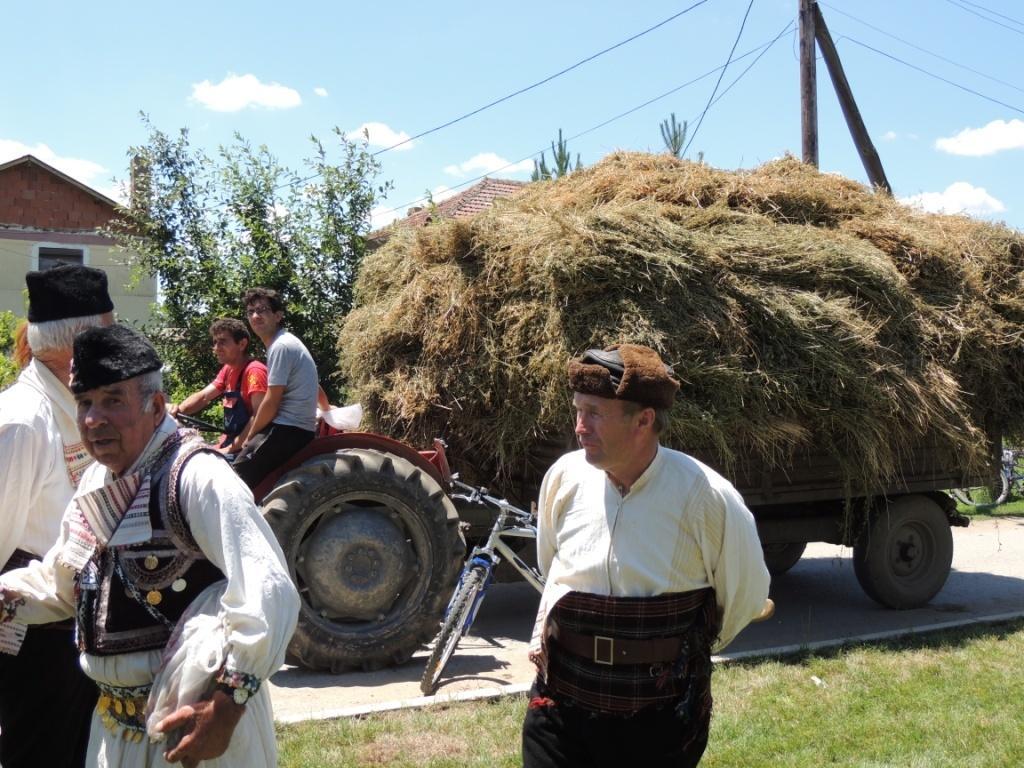Could you give a brief overview of what you see in this image? In this image we can see few people some of them are standing on the ground, there is a truck with grass on the road and a person is driving and a person is sitting on the truck, there is a bicycle beside the truck and there are few trees, buildings, poles, wires and the sky with clouds. 